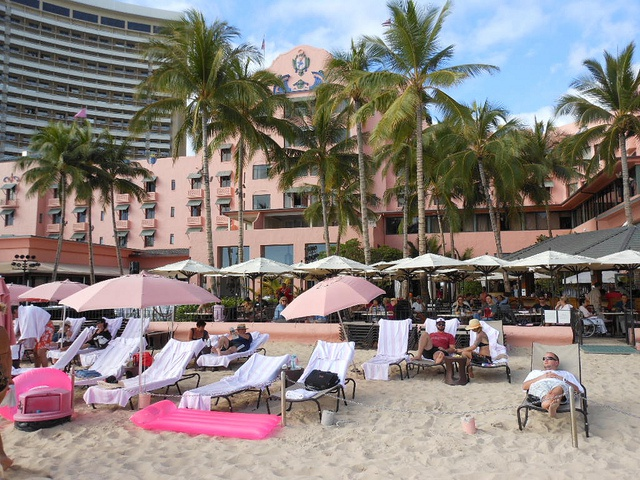Describe the objects in this image and their specific colors. I can see people in black, gray, and maroon tones, umbrella in black, pink, and lightpink tones, chair in black, lavender, darkgray, and gray tones, chair in black, lavender, darkgray, and pink tones, and umbrella in black, pink, and darkgray tones in this image. 